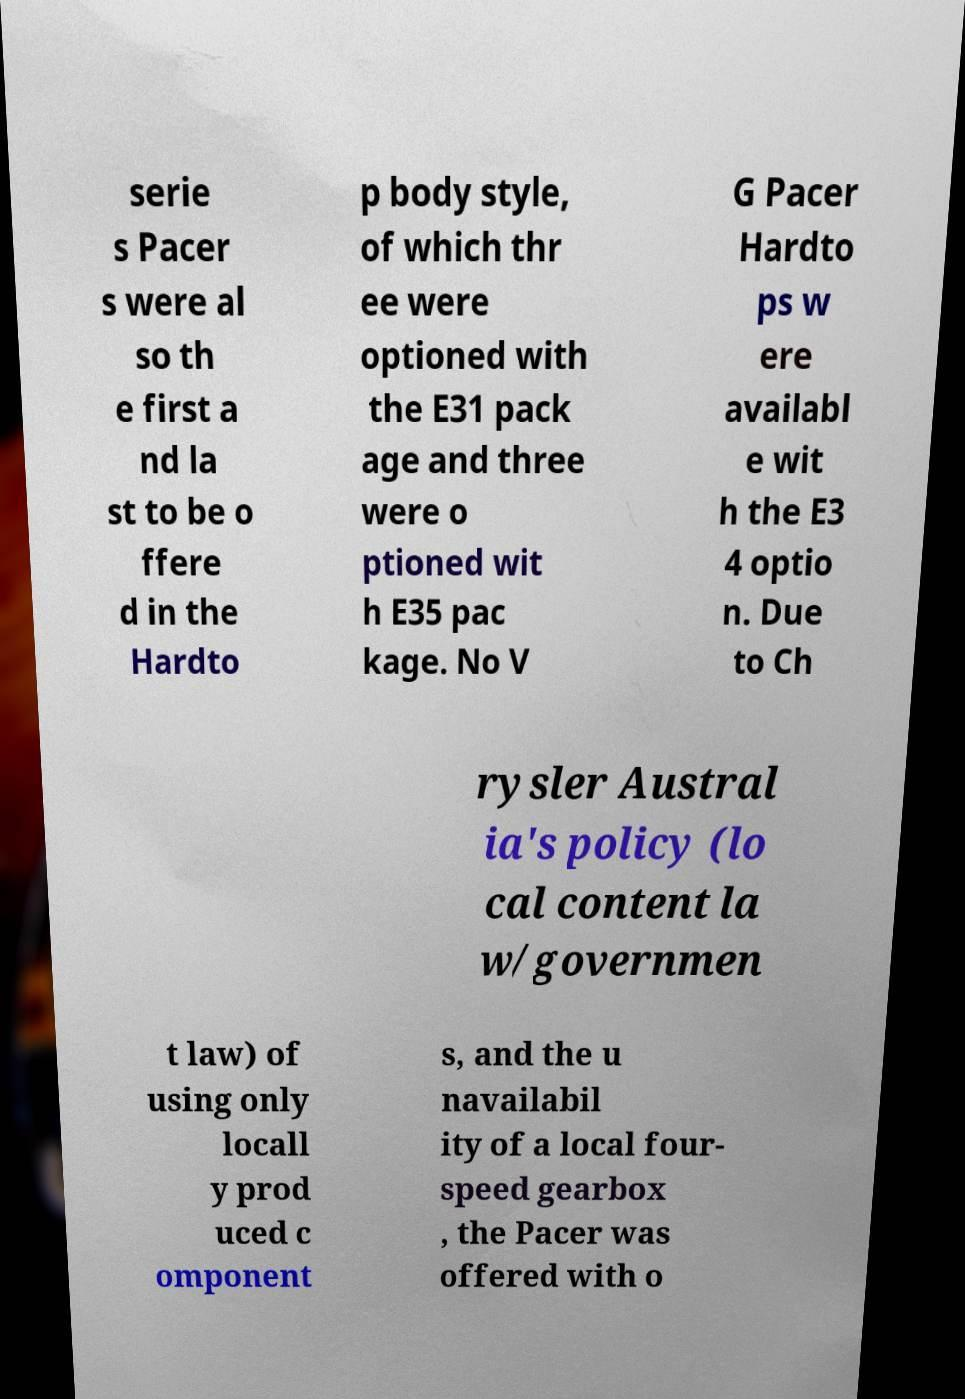Could you assist in decoding the text presented in this image and type it out clearly? serie s Pacer s were al so th e first a nd la st to be o ffere d in the Hardto p body style, of which thr ee were optioned with the E31 pack age and three were o ptioned wit h E35 pac kage. No V G Pacer Hardto ps w ere availabl e wit h the E3 4 optio n. Due to Ch rysler Austral ia's policy (lo cal content la w/governmen t law) of using only locall y prod uced c omponent s, and the u navailabil ity of a local four- speed gearbox , the Pacer was offered with o 